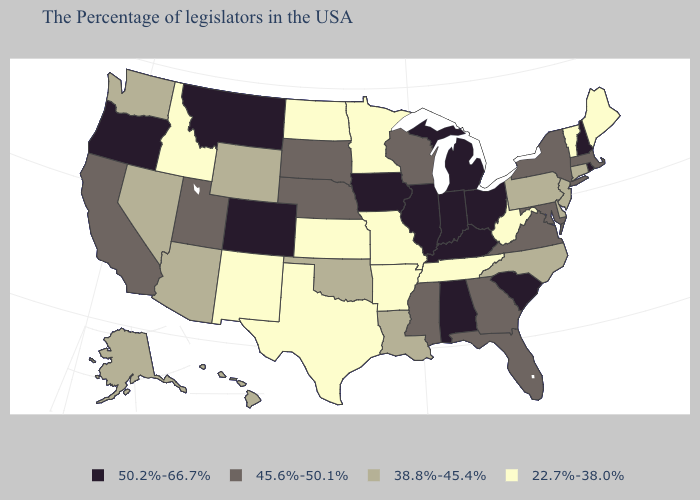Name the states that have a value in the range 45.6%-50.1%?
Write a very short answer. Massachusetts, New York, Maryland, Virginia, Florida, Georgia, Wisconsin, Mississippi, Nebraska, South Dakota, Utah, California. Name the states that have a value in the range 45.6%-50.1%?
Write a very short answer. Massachusetts, New York, Maryland, Virginia, Florida, Georgia, Wisconsin, Mississippi, Nebraska, South Dakota, Utah, California. Does Louisiana have the highest value in the USA?
Concise answer only. No. Name the states that have a value in the range 50.2%-66.7%?
Concise answer only. Rhode Island, New Hampshire, South Carolina, Ohio, Michigan, Kentucky, Indiana, Alabama, Illinois, Iowa, Colorado, Montana, Oregon. What is the value of Kentucky?
Answer briefly. 50.2%-66.7%. What is the lowest value in states that border South Carolina?
Answer briefly. 38.8%-45.4%. What is the highest value in states that border Arkansas?
Concise answer only. 45.6%-50.1%. Name the states that have a value in the range 38.8%-45.4%?
Quick response, please. Connecticut, New Jersey, Delaware, Pennsylvania, North Carolina, Louisiana, Oklahoma, Wyoming, Arizona, Nevada, Washington, Alaska, Hawaii. Does Wyoming have the highest value in the West?
Give a very brief answer. No. Among the states that border Arkansas , does Tennessee have the lowest value?
Quick response, please. Yes. What is the value of California?
Concise answer only. 45.6%-50.1%. Among the states that border New Mexico , which have the lowest value?
Short answer required. Texas. What is the value of Delaware?
Write a very short answer. 38.8%-45.4%. What is the lowest value in the West?
Give a very brief answer. 22.7%-38.0%. Does Wyoming have a lower value than Arkansas?
Concise answer only. No. 